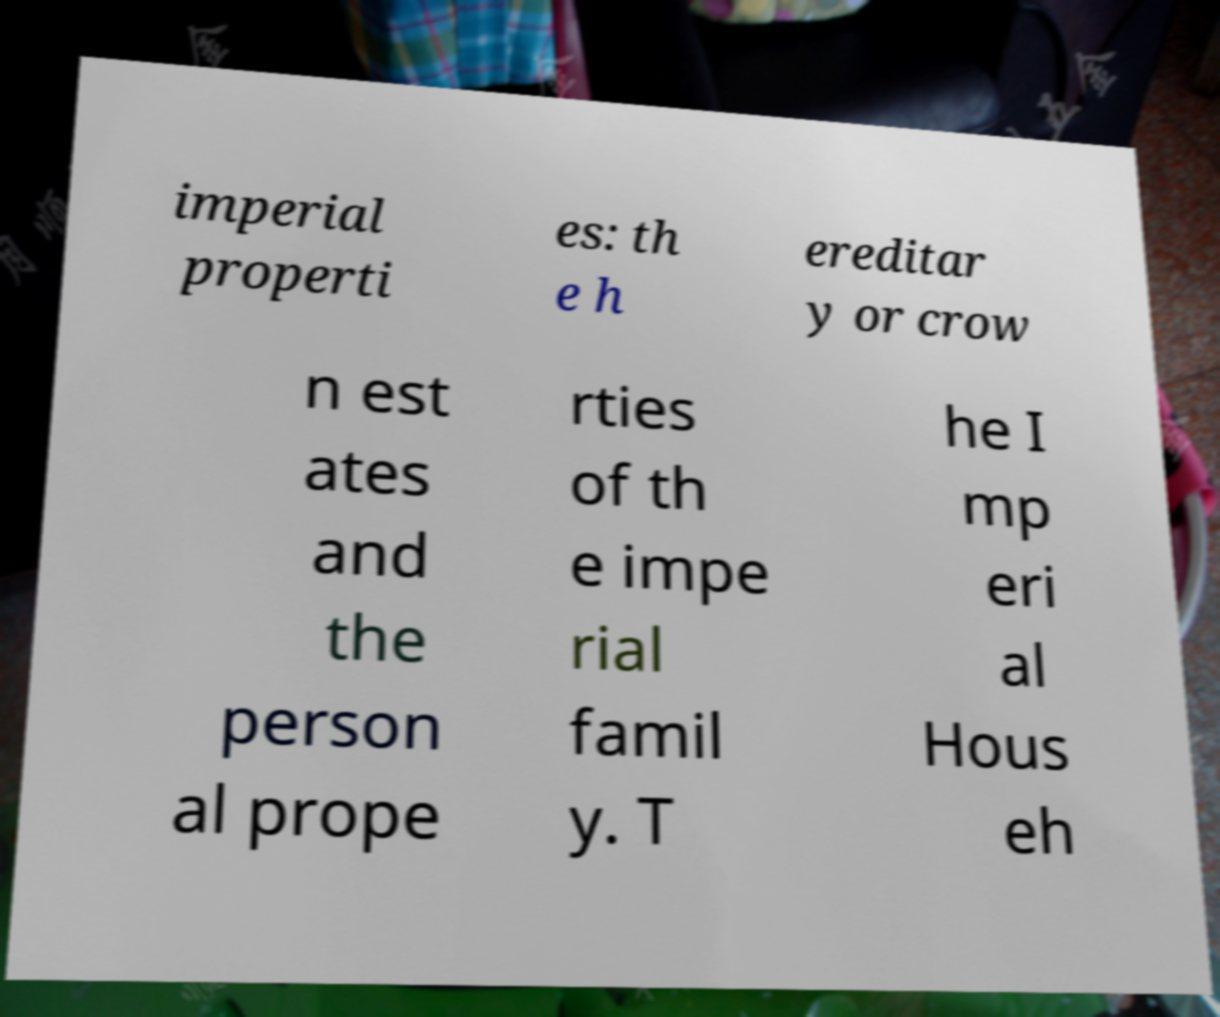Can you read and provide the text displayed in the image?This photo seems to have some interesting text. Can you extract and type it out for me? imperial properti es: th e h ereditar y or crow n est ates and the person al prope rties of th e impe rial famil y. T he I mp eri al Hous eh 